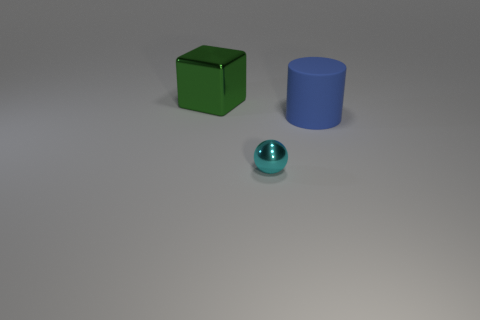Are there any other things that have the same material as the big blue cylinder?
Offer a terse response. No. Are there any other things that are the same size as the cyan metal sphere?
Keep it short and to the point. No. The shiny object that is in front of the metal object left of the small ball is what color?
Give a very brief answer. Cyan. How many things are small cyan shiny objects or big objects behind the large blue cylinder?
Offer a very short reply. 2. There is a metallic thing that is right of the big block; what color is it?
Provide a short and direct response. Cyan. What is the shape of the large green metal thing?
Your answer should be compact. Cube. The large thing on the left side of the object that is in front of the rubber cylinder is made of what material?
Keep it short and to the point. Metal. What number of other things are made of the same material as the green cube?
Provide a short and direct response. 1. There is a thing that is the same size as the blue cylinder; what is its material?
Ensure brevity in your answer.  Metal. Is the number of cylinders in front of the blue thing greater than the number of blue matte things on the right side of the small cyan shiny object?
Ensure brevity in your answer.  No. 